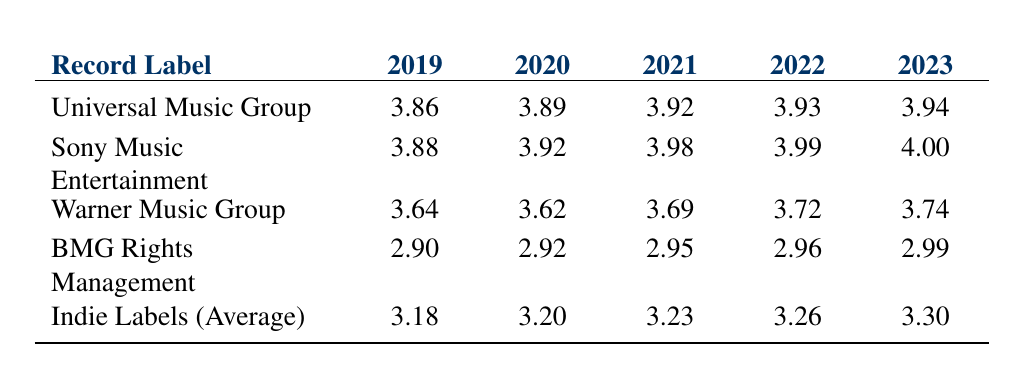What was the annual revenue of Universal Music Group in 2021? According to the table for the year 2021, the value for Universal Music Group is shown directly as 3.92.
Answer: 3.92 Which record label had the highest annual revenue in 2022? By examining the 2022 values: Universal (3.93), Sony (3.99), Warner (3.72), BMG (2.96), and Indie Labels (3.26), Sony Music Entertainment has the highest value of 3.99.
Answer: Sony Music Entertainment What is the average annual revenue of Indie Labels from 2019 to 2023? To calculate the average, sum the values: 3.18 + 3.20 + 3.23 + 3.26 + 3.30 = 16.17, then divide by 5, giving 16.17 / 5 = 3.234.
Answer: 3.234 Is BMG Rights Management's revenue in 2023 lower than Warner Music Group's revenue in that same year? BMG's revenue for 2023 is 2.99, and Warner's is 3.74; since 2.99 is less than 3.74, the statement is true.
Answer: Yes What is the difference in annual revenue between Sony Music Entertainment's 2021 and Warner Music Group's 2021? Sony's revenue for 2021 is 3.98, and Warner's is 3.69; calculating the difference gives 3.98 - 3.69 = 0.29.
Answer: 0.29 How much did Universal Music Group's revenue increase from 2019 to 2023? The revenue in 2019 is 3.86 and in 2023 is 3.94; the increase is calculated as 3.94 - 3.86 = 0.08.
Answer: 0.08 Is the annual revenue of Indie Labels (Average) higher than that of BMG Rights Management in all years from 2019 to 2023? By checking the values: Indie: 3.18 to 3.30, BMG: 2.90 to 2.99, Indie is higher in every year; therefore, the statement is true.
Answer: Yes Which record label had the smallest revenue in 2020? Looking at the 2020 column, the values are Universal (3.89), Sony (3.92), Warner (3.62), BMG (2.92), and Indie (3.20); Warner Music Group has the smallest value of 3.62.
Answer: Warner Music Group 